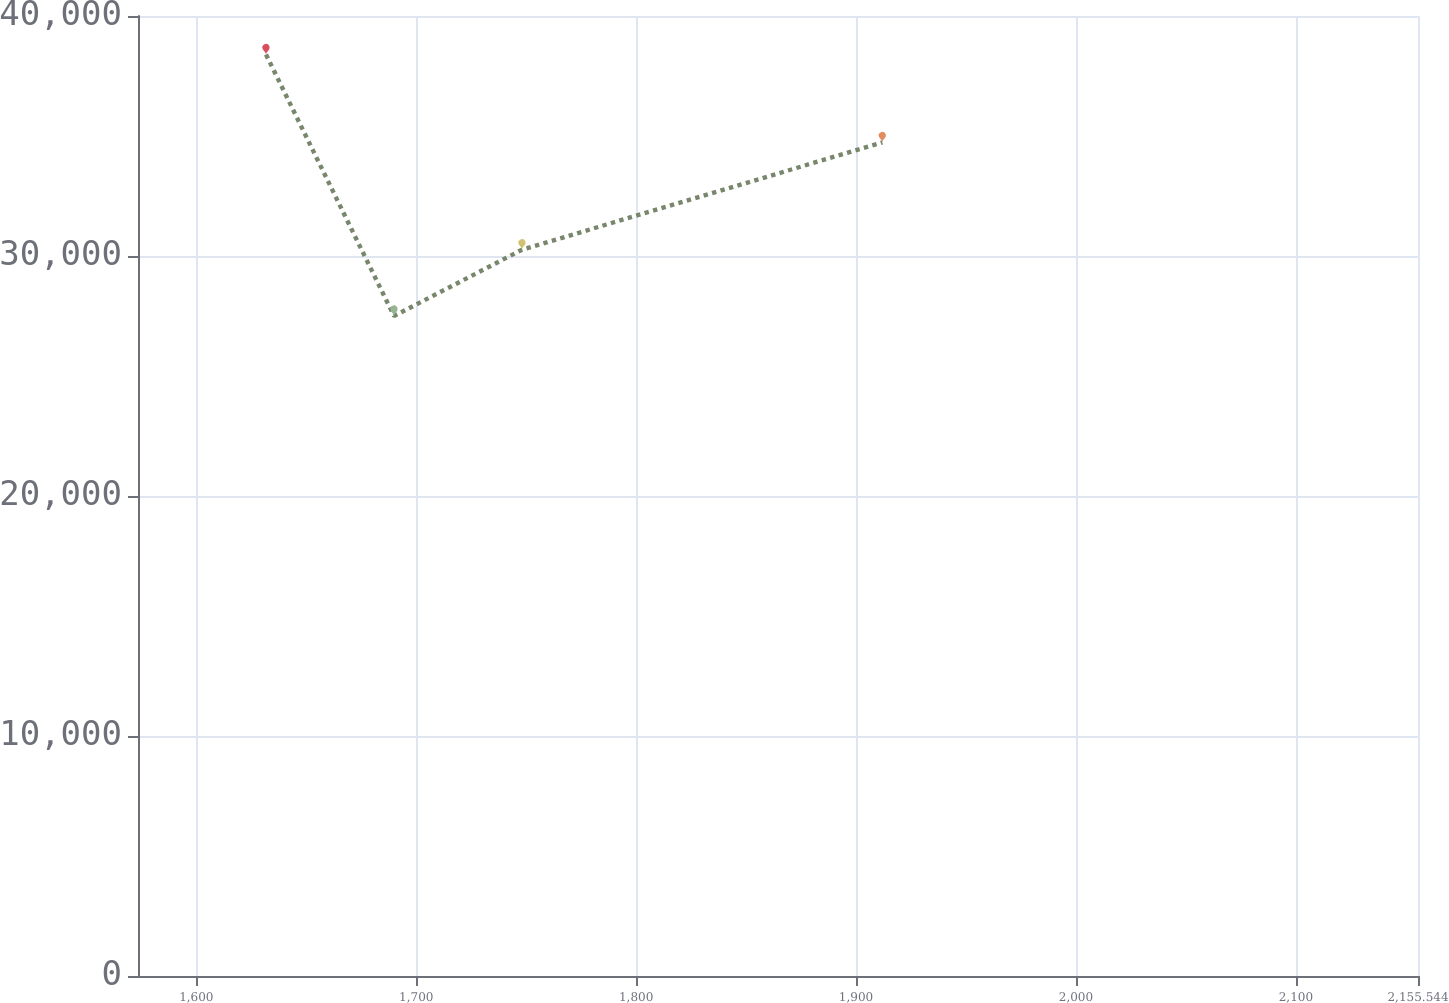<chart> <loc_0><loc_0><loc_500><loc_500><line_chart><ecel><fcel>Unnamed: 1<nl><fcel>1631.69<fcel>38396.8<nl><fcel>1689.9<fcel>27501.1<nl><fcel>1748.11<fcel>30263<nl><fcel>1911.95<fcel>34732.5<nl><fcel>2213.75<fcel>24289.4<nl></chart> 